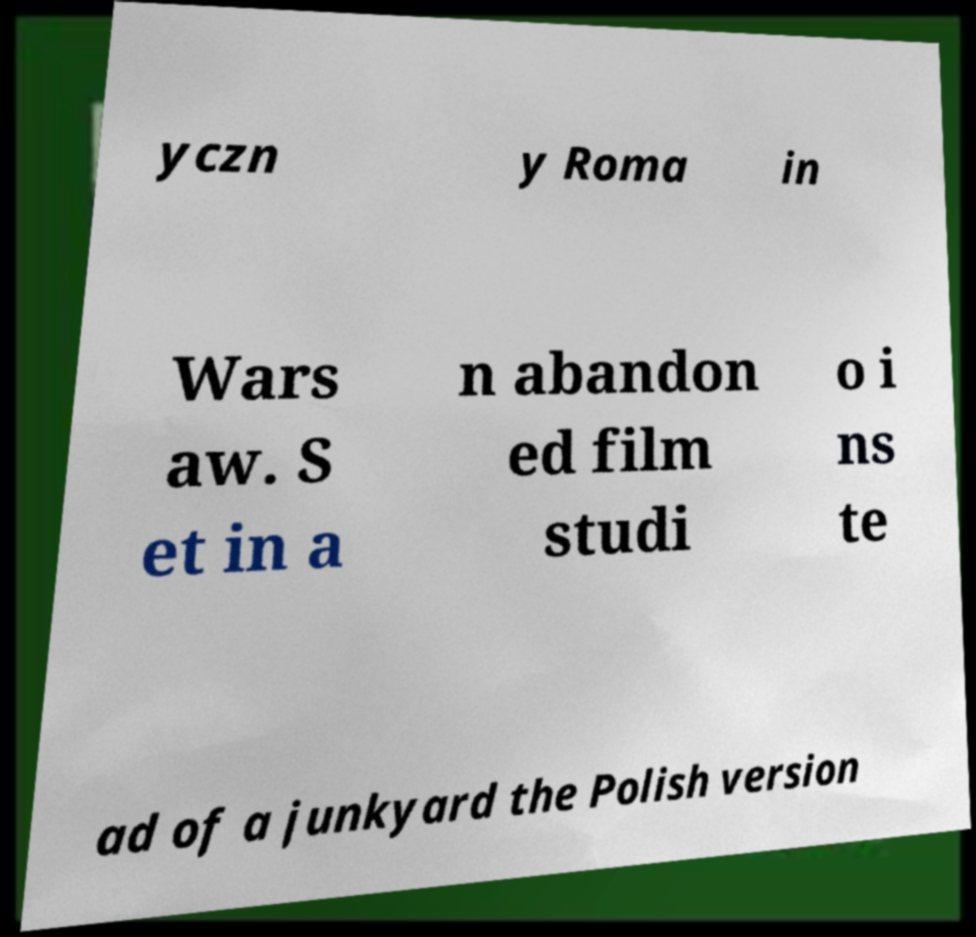There's text embedded in this image that I need extracted. Can you transcribe it verbatim? yczn y Roma in Wars aw. S et in a n abandon ed film studi o i ns te ad of a junkyard the Polish version 